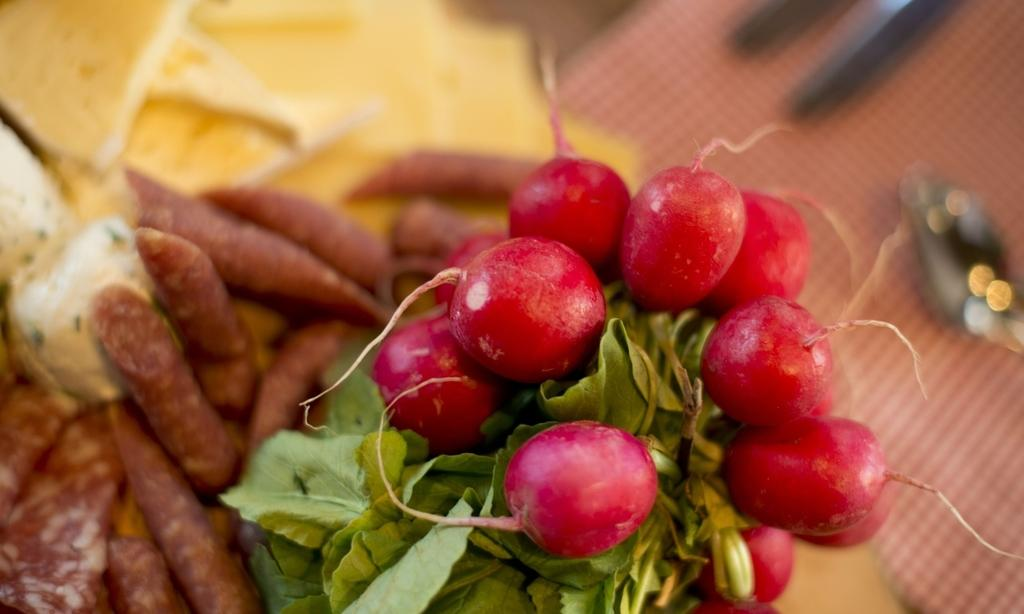What types of vegetables are present in the image? There are radishes and sweet potatoes in the image. Where are the vegetables located? The vegetables are placed on a table. What utensil is beside the vegetables? There is a spoon beside the vegetables. How many kittens are playing with the radishes in the image? There are no kittens present in the image; it only features radishes and sweet potatoes on a table. 